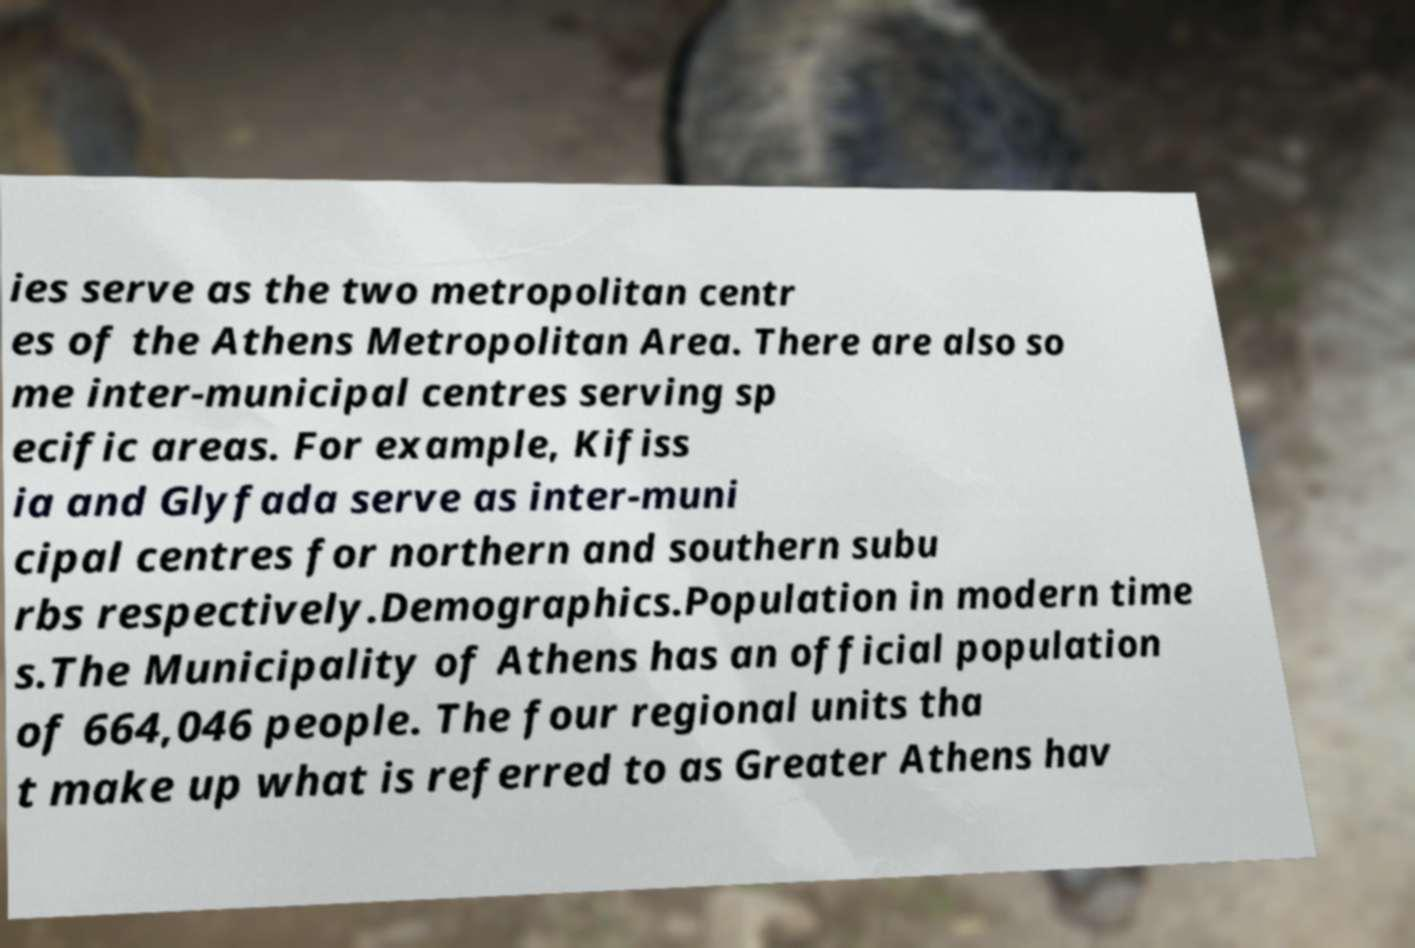What messages or text are displayed in this image? I need them in a readable, typed format. ies serve as the two metropolitan centr es of the Athens Metropolitan Area. There are also so me inter-municipal centres serving sp ecific areas. For example, Kifiss ia and Glyfada serve as inter-muni cipal centres for northern and southern subu rbs respectively.Demographics.Population in modern time s.The Municipality of Athens has an official population of 664,046 people. The four regional units tha t make up what is referred to as Greater Athens hav 